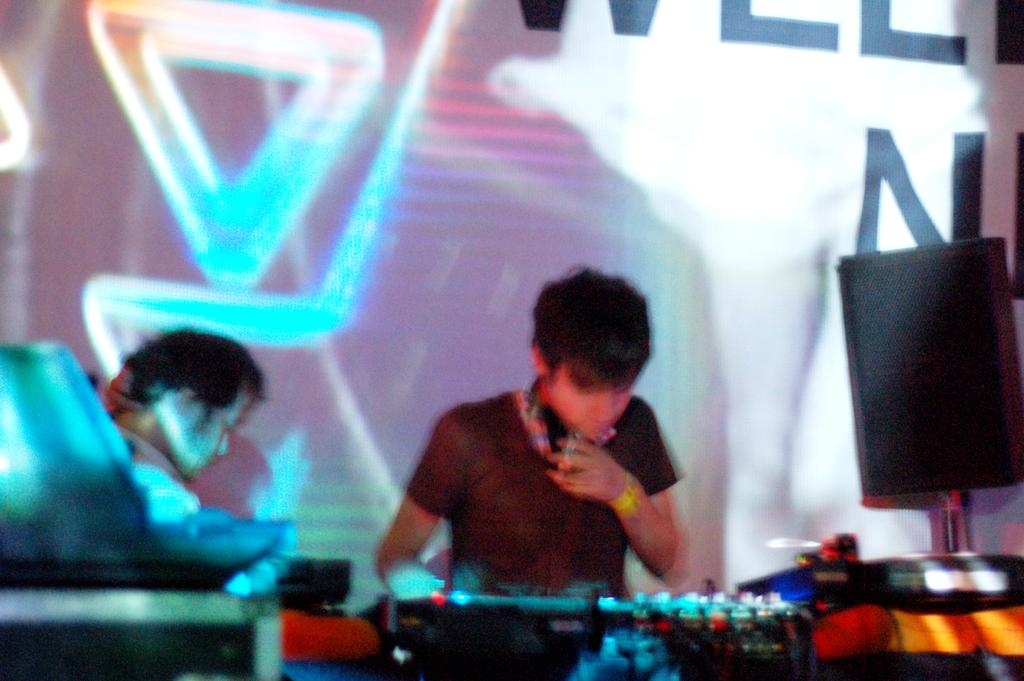What are the people in the image doing? Some of the people are playing musical instruments. What else can be seen in the image besides the people? There is a banner on the wall and a speaker on a pole in the image. What reason does the knee have for turning the page in the image? There is no knee or page present in the image, so this question cannot be answered. 